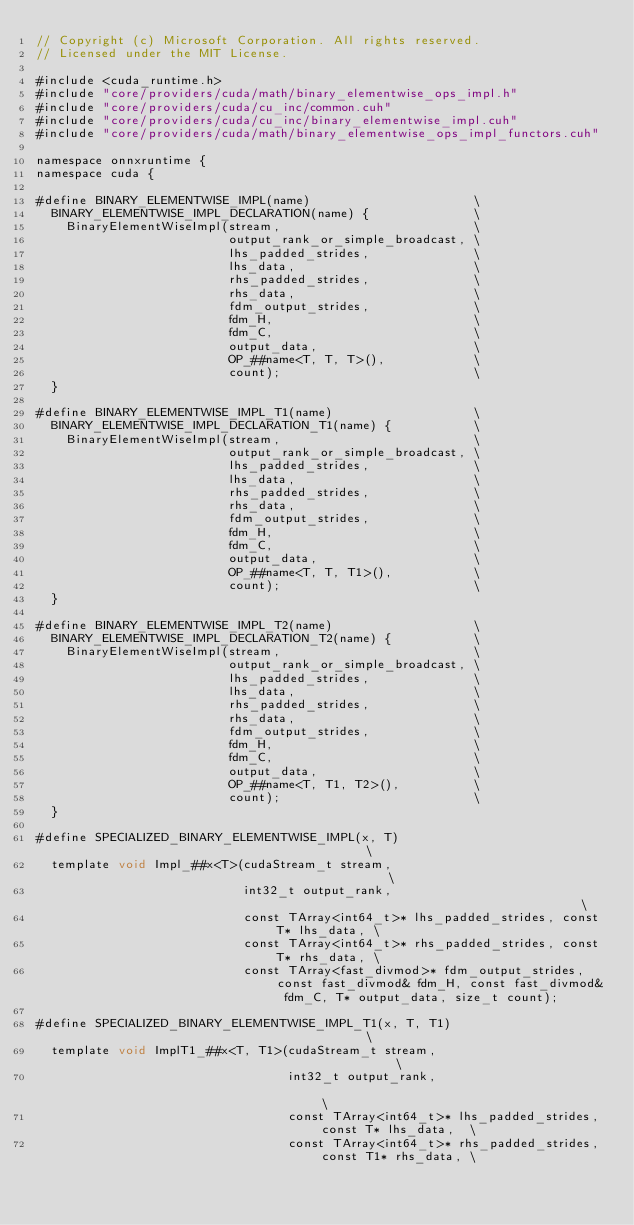Convert code to text. <code><loc_0><loc_0><loc_500><loc_500><_Cuda_>// Copyright (c) Microsoft Corporation. All rights reserved.
// Licensed under the MIT License.

#include <cuda_runtime.h>
#include "core/providers/cuda/math/binary_elementwise_ops_impl.h"
#include "core/providers/cuda/cu_inc/common.cuh"
#include "core/providers/cuda/cu_inc/binary_elementwise_impl.cuh"
#include "core/providers/cuda/math/binary_elementwise_ops_impl_functors.cuh"

namespace onnxruntime {
namespace cuda {

#define BINARY_ELEMENTWISE_IMPL(name)                      \
  BINARY_ELEMENTWISE_IMPL_DECLARATION(name) {              \
    BinaryElementWiseImpl(stream,                          \
                          output_rank_or_simple_broadcast, \
                          lhs_padded_strides,              \
                          lhs_data,                        \
                          rhs_padded_strides,              \
                          rhs_data,                        \
                          fdm_output_strides,              \
                          fdm_H,                           \
                          fdm_C,                           \
                          output_data,                     \
                          OP_##name<T, T, T>(),            \
                          count);                          \
  }

#define BINARY_ELEMENTWISE_IMPL_T1(name)                   \
  BINARY_ELEMENTWISE_IMPL_DECLARATION_T1(name) {           \
    BinaryElementWiseImpl(stream,                          \
                          output_rank_or_simple_broadcast, \
                          lhs_padded_strides,              \
                          lhs_data,                        \
                          rhs_padded_strides,              \
                          rhs_data,                        \
                          fdm_output_strides,              \
                          fdm_H,                           \
                          fdm_C,                           \
                          output_data,                     \
                          OP_##name<T, T, T1>(),           \
                          count);                          \
  }

#define BINARY_ELEMENTWISE_IMPL_T2(name)                   \
  BINARY_ELEMENTWISE_IMPL_DECLARATION_T2(name) {           \
    BinaryElementWiseImpl(stream,                          \
                          output_rank_or_simple_broadcast, \
                          lhs_padded_strides,              \
                          lhs_data,                        \
                          rhs_padded_strides,              \
                          rhs_data,                        \
                          fdm_output_strides,              \
                          fdm_H,                           \
                          fdm_C,                           \
                          output_data,                     \
                          OP_##name<T, T1, T2>(),          \
                          count);                          \
  }

#define SPECIALIZED_BINARY_ELEMENTWISE_IMPL(x, T)                                         \
  template void Impl_##x<T>(cudaStream_t stream,                                          \
                            int32_t output_rank,                                          \
                            const TArray<int64_t>* lhs_padded_strides, const T* lhs_data, \
                            const TArray<int64_t>* rhs_padded_strides, const T* rhs_data, \
                            const TArray<fast_divmod>* fdm_output_strides, const fast_divmod& fdm_H, const fast_divmod& fdm_C, T* output_data, size_t count);

#define SPECIALIZED_BINARY_ELEMENTWISE_IMPL_T1(x, T, T1)                                         \
  template void ImplT1_##x<T, T1>(cudaStream_t stream,                                           \
                                  int32_t output_rank,                                           \
                                  const TArray<int64_t>* lhs_padded_strides, const T* lhs_data,  \
                                  const TArray<int64_t>* rhs_padded_strides, const T1* rhs_data, \</code> 